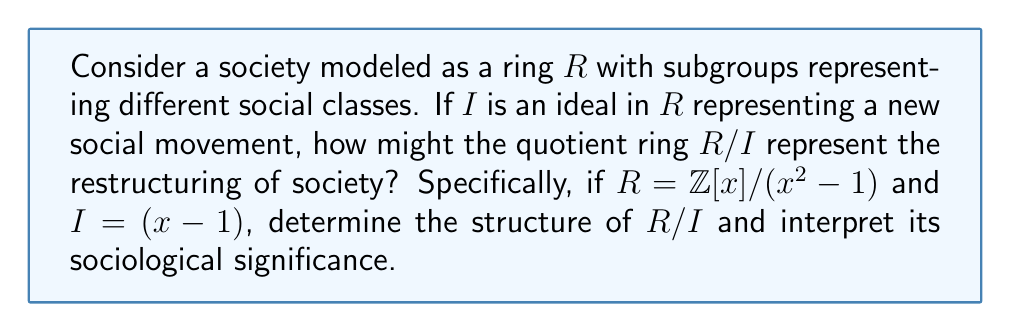Provide a solution to this math problem. To solve this problem, we'll follow these steps:

1) First, let's understand what $R = \mathbb{Z}[x]/(x^2-1)$ represents:
   This is the ring of polynomials with integer coefficients, modulo the relation $x^2 = 1$.

2) Now, we need to consider the ideal $I = (x-1)$ in this ring.

3) The quotient ring $R/I$ will identify all elements that differ by a multiple of $(x-1)$.

4) In $R$, we have $x^2 = 1$, so $x^2 - 1 = 0$, or $(x-1)(x+1) = 0$.

5) When we further quotient by $(x-1)$, we're essentially setting $x = 1$ in the ring.

6) This means that in $R/I$, every element can be represented uniquely by an integer.

7) Algebraically, we can show that $R/I \cong \mathbb{Z}$:

   Let $\phi: R \to \mathbb{Z}$ be the homomorphism that evaluates polynomials at $x = 1$.
   The kernel of $\phi$ is precisely $I$, so by the First Isomorphism Theorem, $R/I \cong \mathbb{Z}$.

Sociological Interpretation:

- The original ring $R$ represents a society with a complex structure (polynomials in $x$).
- The ideal $I = (x-1)$ represents a social movement that aims to "equalize" or "standardize" some aspect of society (setting $x = 1$).
- The resulting quotient ring $R/I \cong \mathbb{Z}$ represents a simplified, more homogeneous society where individuals are distinguished only by a single integer value (perhaps wealth or social status).

This model suggests that certain social movements can lead to a restructuring of society that reduces complexity but may also reduce diversity, as the rich structure of polynomials is reduced to simple integers.
Answer: $R/I \cong \mathbb{Z}$, representing a society restructured into a linear hierarchy based on a single attribute. 